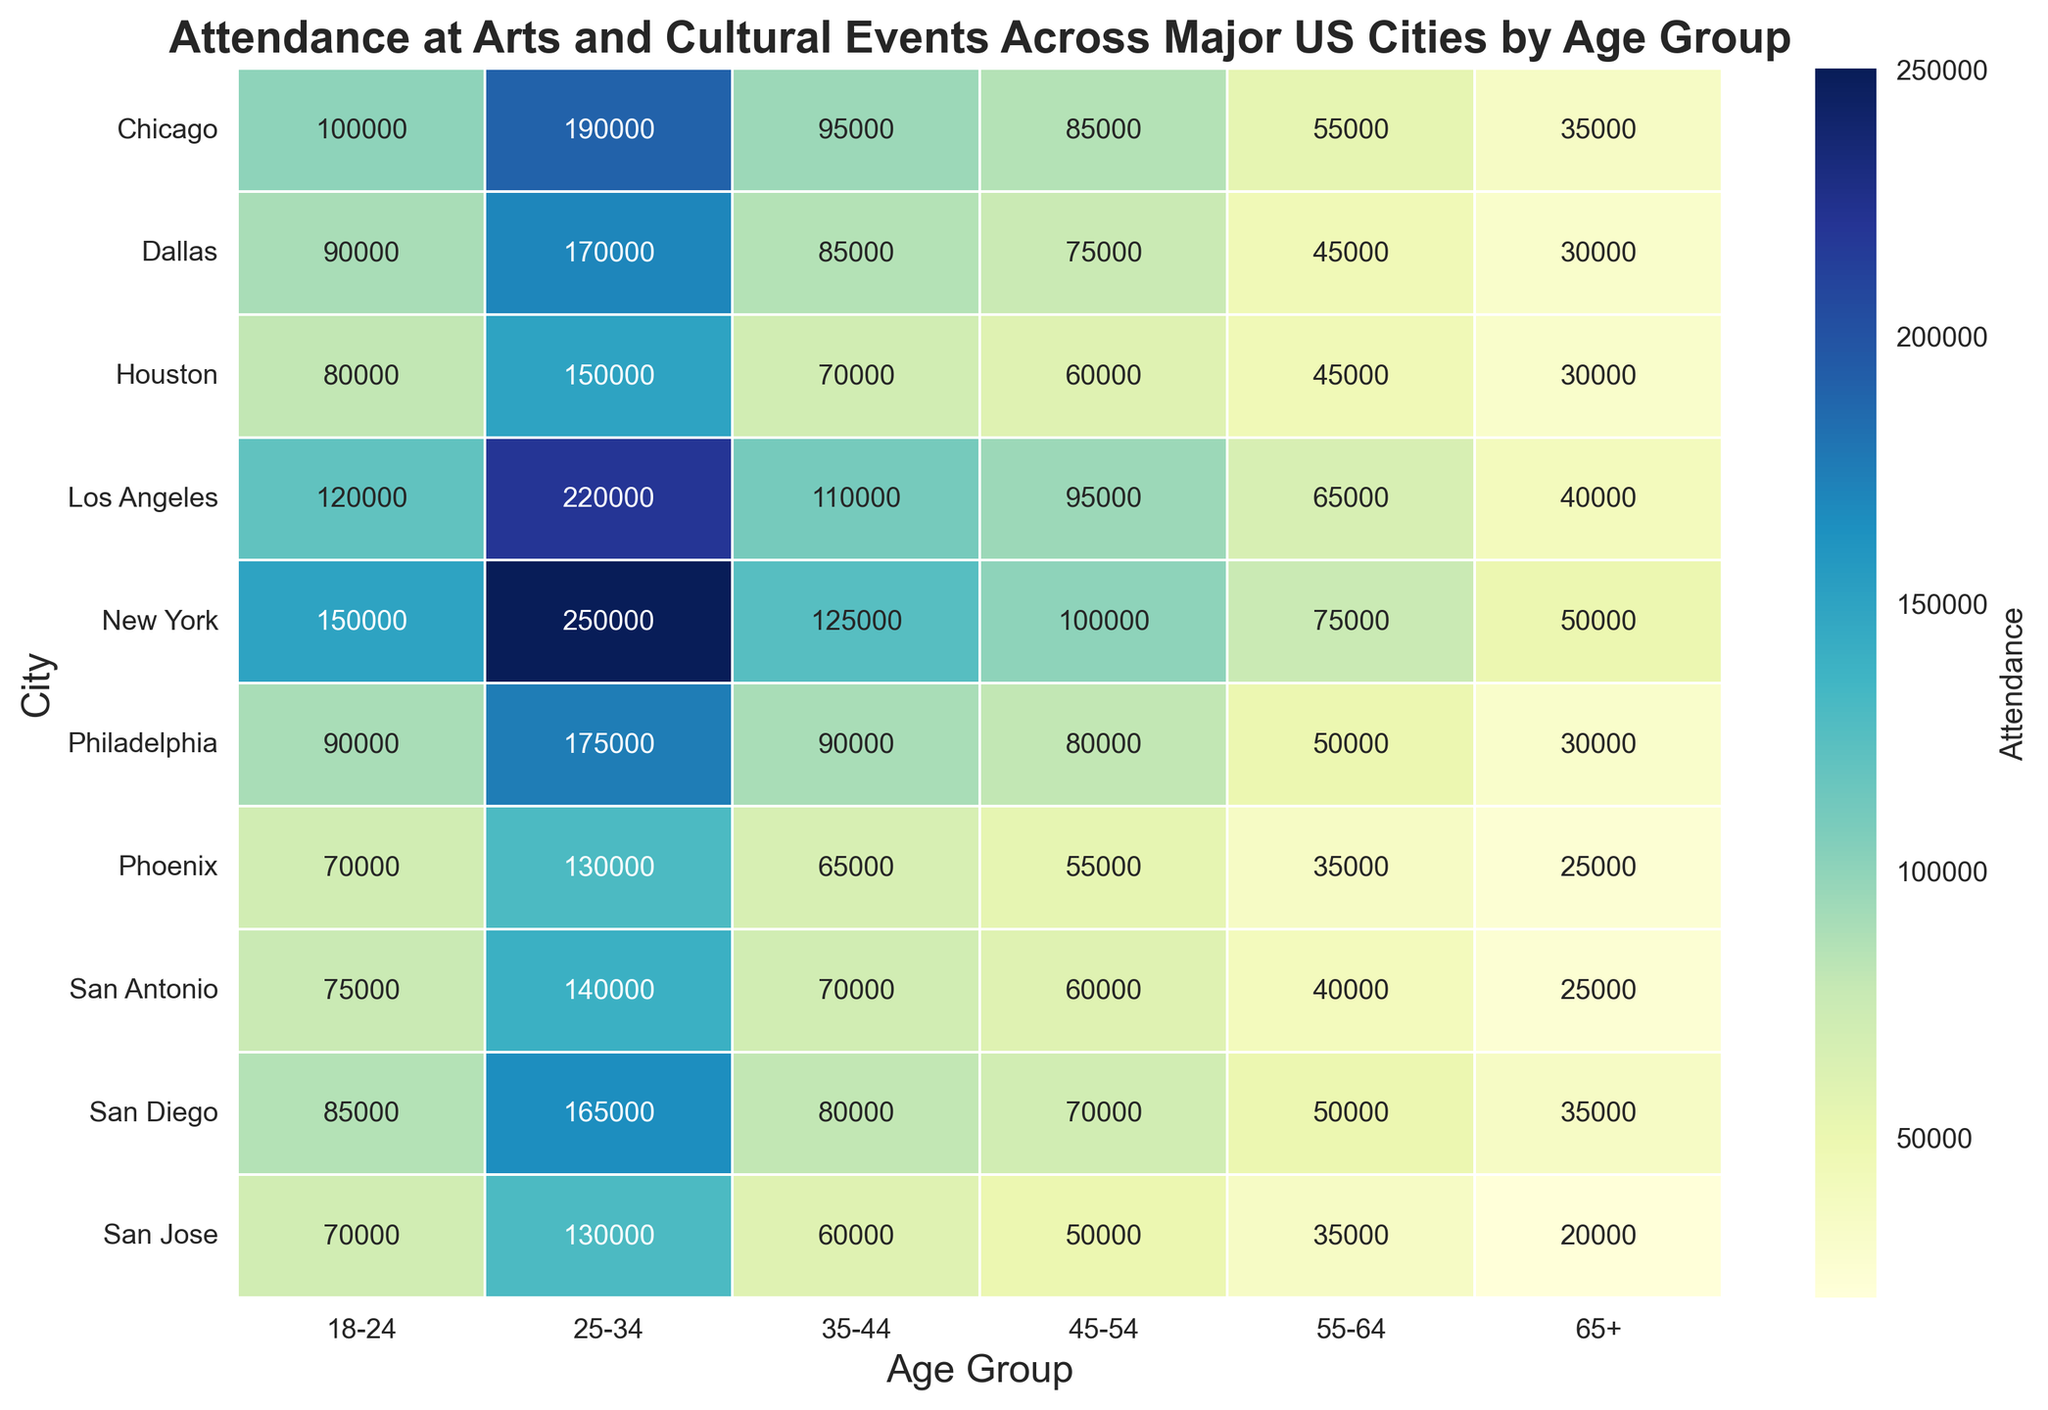Which city has the highest attendance in the 25-34 age group? To find the city with the highest attendance for the 25-34 age group, locate the 25-34 column on the heatmap and find the highest value among the cities. New York has the highest attendance of 250,000 in this age group.
Answer: New York Which city has the lowest attendance in the 65+ age group? To find the city with the lowest attendance for the 65+ age group, locate the 65+ column on the heatmap and identify the smallest number. San Jose has the lowest attendance of 20,000.
Answer: San Jose What is the total attendance across all age groups for Los Angeles? Sum the individual attendance values for each age group in Los Angeles: 120,000 + 220,000 + 110,000 + 95,000 + 65,000 + 40,000. The total is 650,000.
Answer: 650,000 Compare the attendance of the 18-24 age group in New York and Chicago. Which city has higher attendance? Look at the attendance values for the 18-24 age group in New York and Chicago. New York has 150,000, while Chicago has 100,000. New York has higher attendance.
Answer: New York Which age group has the least attendance in Philadelphia? Scan the attendance values for Philadelphia across all age groups and identify the smallest number. The attendance for the 65+ age group is the lowest at 30,000.
Answer: 65+ What is the average attendance for the 35-44 age group across all cities? Sum the attendance values for the 35-44 age group across all cities and then divide by the number of cities: (125,000 + 110,000 + 95,000 + 70,000 + 65,000 + 90,000 + 70,000 + 80,000 + 85,000 + 60,000) / 10. The total is 850,000, and the average is 85,000.
Answer: 85,000 Which city has the narrowest range of attendance values across all age groups? Calculate the range (difference between the highest and lowest attendance) for each city and find the city with the smallest range. Houston has the narrowest range with a difference of 120,000 (150,000 - 30,000).
Answer: Houston How does the attendance for the 45-54 age group in Phoenix compare to the same age group in Dallas? Look at the attendance values for the 45-54 age group in Phoenix and Dallas. Phoenix has 55,000 while Dallas has 75,000. Dallas has higher attendance.
Answer: Dallas Which city shows the most balanced attendance distribution across all age groups, based on visual observation of similarity in attendance values? By visually observing the heatmap for cities where attendance values for different age groups appear to be similar, New York displays a relatively balanced distribution compared to other cities, though the balance is subjective.
Answer: New York 